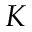<formula> <loc_0><loc_0><loc_500><loc_500>K</formula> 